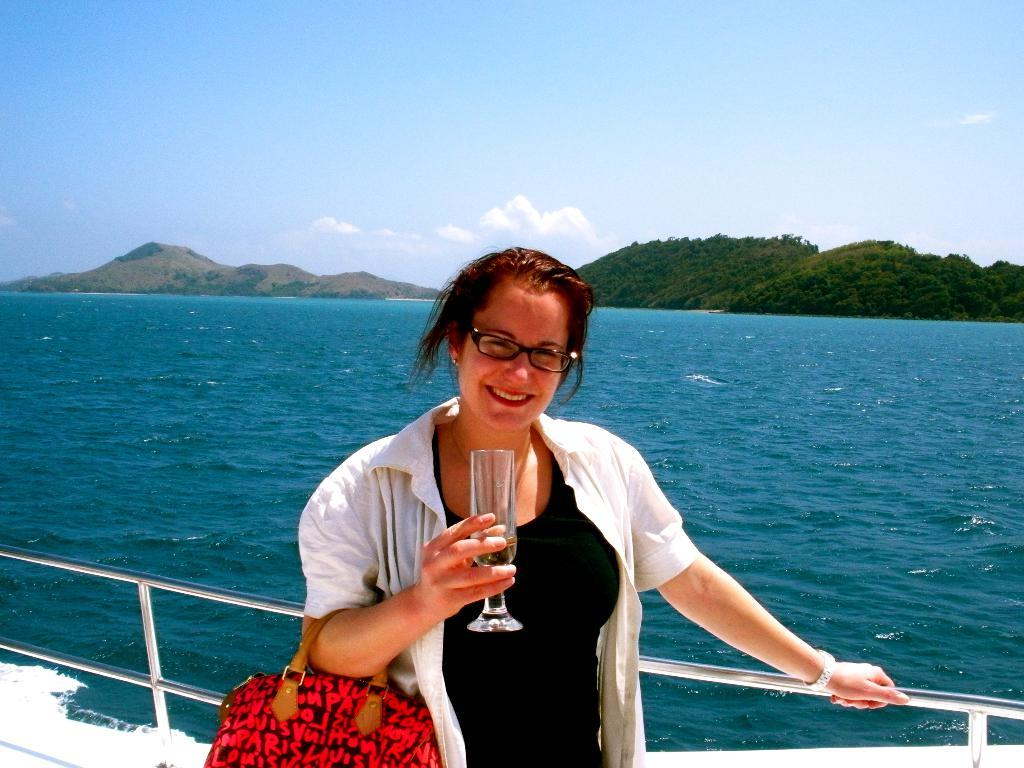Who is present in the image? There is a woman in the image. What is the woman doing in the image? The woman is standing in a ship. What is the woman holding in her hands? The woman is holding a handbag and a glass in her hand. What can be seen in the background of the image? There are hills and water visible in the background, and the sky is sunny. What verse is the woman reciting in the image? There is no indication in the image that the woman is reciting a verse. What type of paint is being used to create the image? The question is not applicable, as we are discussing a photographic image, not a painted one. 